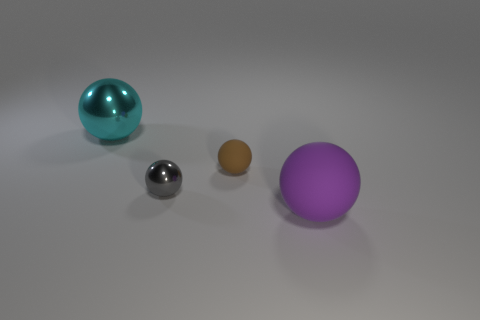How many cyan objects are either balls or big metallic objects?
Give a very brief answer. 1. The sphere that is made of the same material as the large purple thing is what color?
Provide a succinct answer. Brown. Does the small rubber thing have the same color as the large sphere in front of the big cyan thing?
Make the answer very short. No. What color is the thing that is both behind the small gray metallic sphere and left of the tiny rubber ball?
Your answer should be compact. Cyan. There is a purple sphere; what number of tiny matte spheres are behind it?
Offer a very short reply. 1. What number of objects are large yellow metal cylinders or shiny objects in front of the cyan thing?
Provide a succinct answer. 1. Are there any big cyan things that are in front of the thing that is to the left of the small gray thing?
Provide a succinct answer. No. What color is the rubber sphere that is behind the gray metallic object?
Your answer should be very brief. Brown. Are there the same number of rubber things behind the large cyan ball and small cyan cylinders?
Offer a terse response. Yes. What shape is the thing that is both right of the tiny shiny sphere and in front of the tiny brown rubber ball?
Offer a terse response. Sphere. 